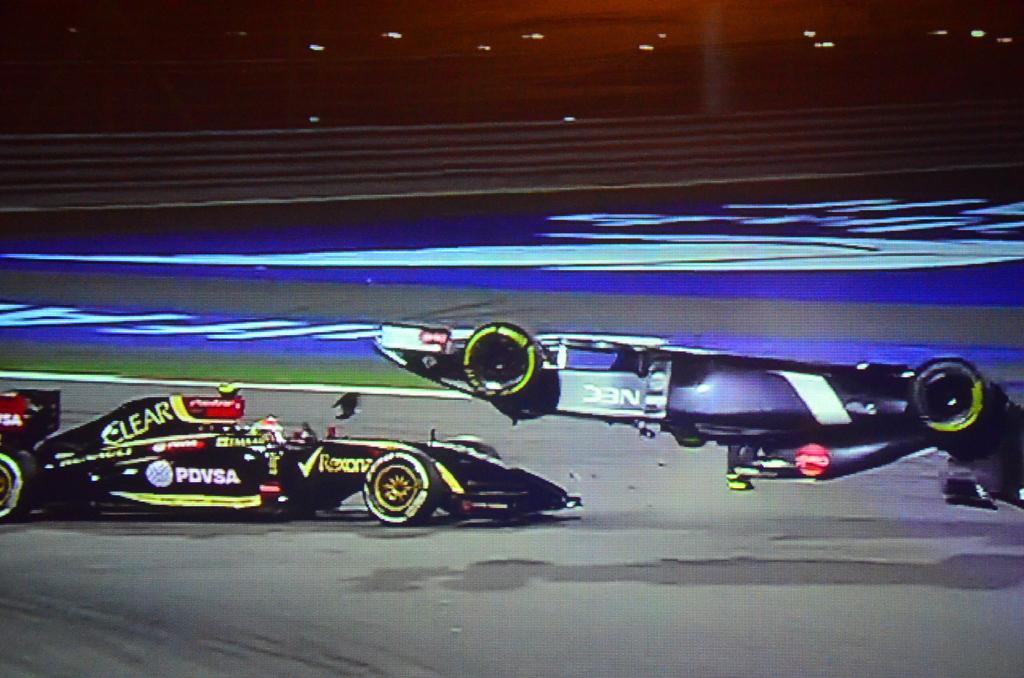Who sponsors the upside down racecar?
Your answer should be compact. Nec. What is the brand of the car that is right side up?
Offer a terse response. Unanswerable. 